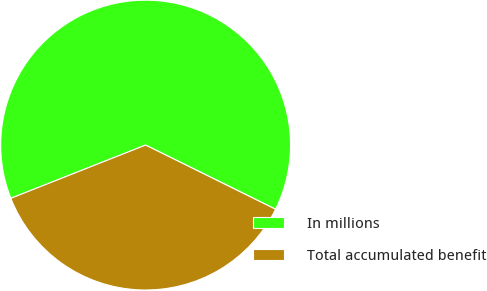Convert chart. <chart><loc_0><loc_0><loc_500><loc_500><pie_chart><fcel>In millions<fcel>Total accumulated benefit<nl><fcel>63.29%<fcel>36.71%<nl></chart> 